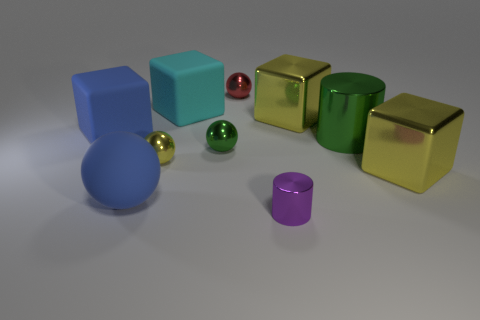Are there more tiny red spheres behind the green metal cylinder than big rubber balls in front of the large sphere?
Ensure brevity in your answer.  Yes. There is a green cylinder that is the same size as the cyan thing; what is it made of?
Provide a succinct answer. Metal. How many big objects are either green metal objects or red metal objects?
Your response must be concise. 1. Does the tiny red object have the same shape as the tiny yellow metallic thing?
Offer a terse response. Yes. How many big objects are left of the tiny green object and behind the big green thing?
Offer a very short reply. 2. Are there any other things of the same color as the rubber ball?
Your answer should be very brief. Yes. What is the shape of the tiny red object that is made of the same material as the small purple object?
Provide a succinct answer. Sphere. Is the blue matte block the same size as the green metallic cylinder?
Provide a short and direct response. Yes. Is the yellow object that is left of the cyan block made of the same material as the large blue sphere?
Ensure brevity in your answer.  No. There is a large yellow metal object that is behind the cylinder that is behind the purple cylinder; how many large objects are on the right side of it?
Give a very brief answer. 2. 